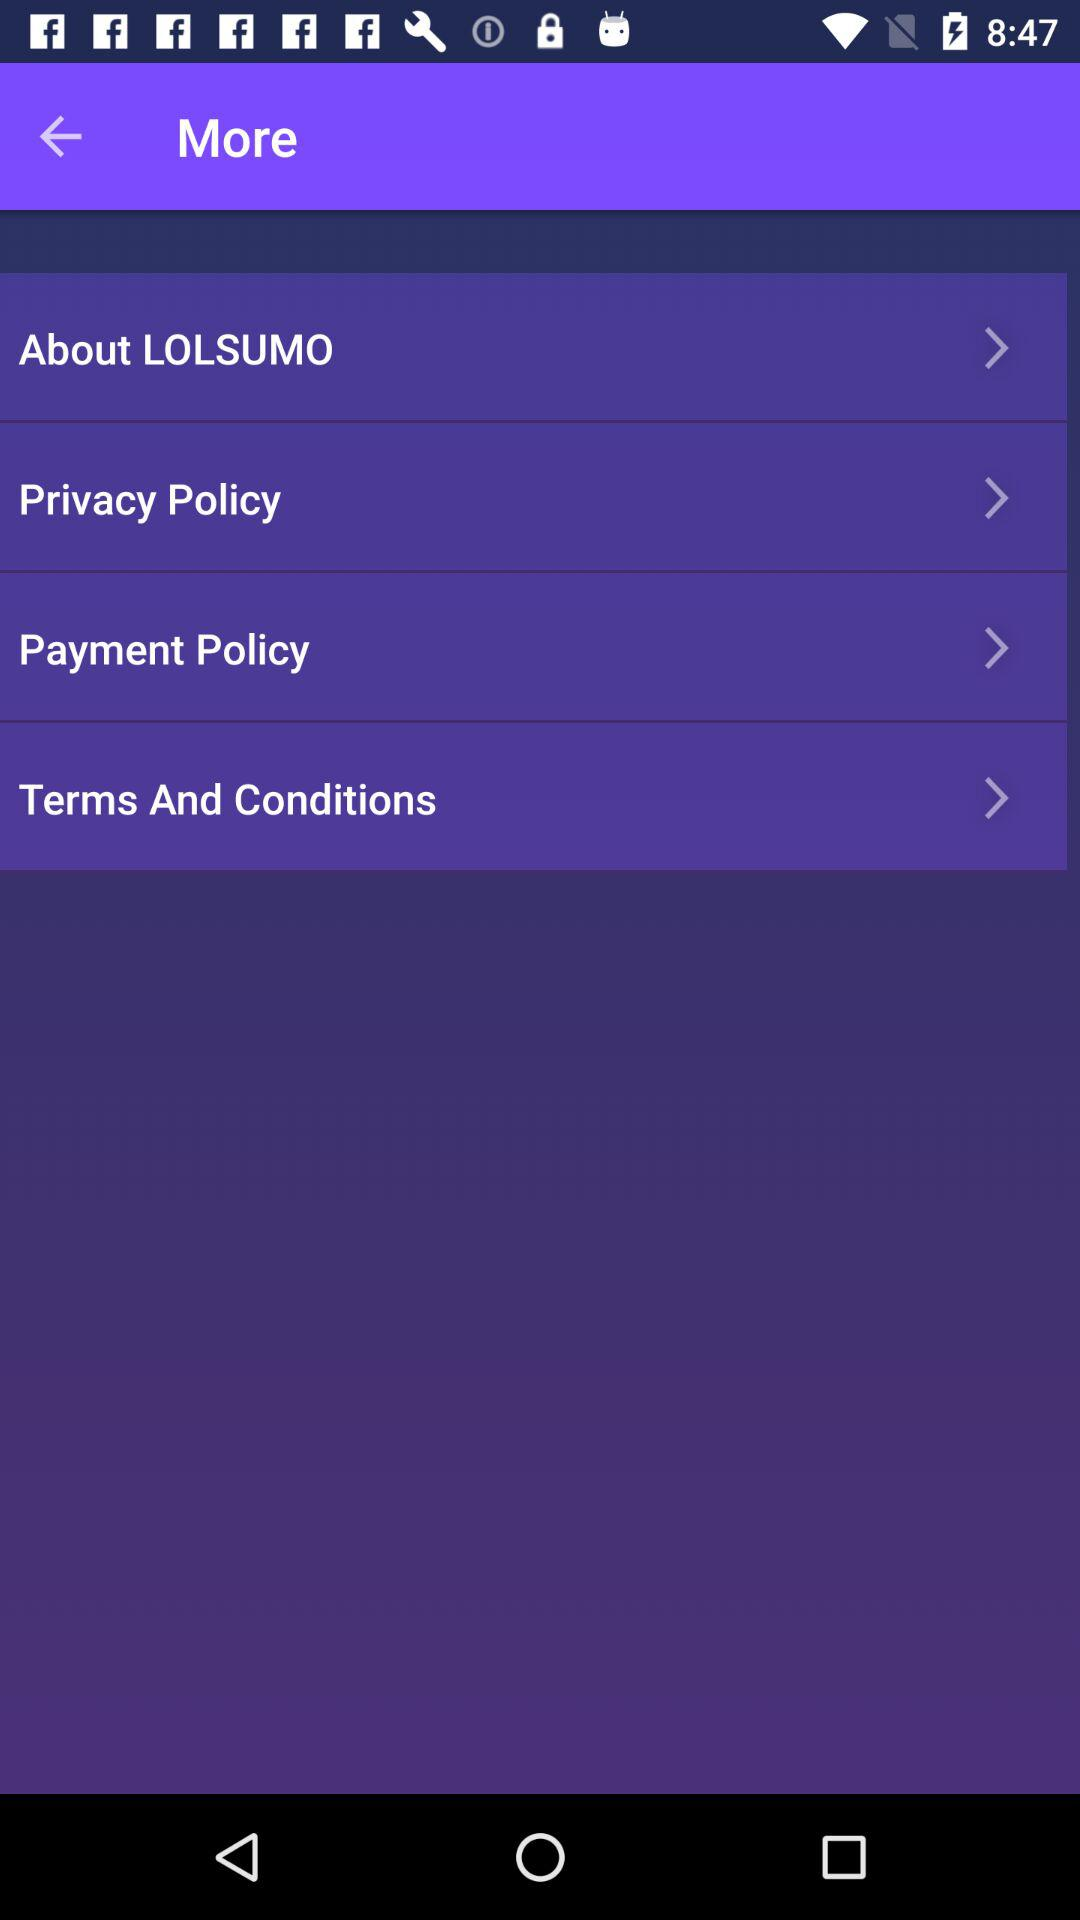How many items have an arrow forward?
Answer the question using a single word or phrase. 4 